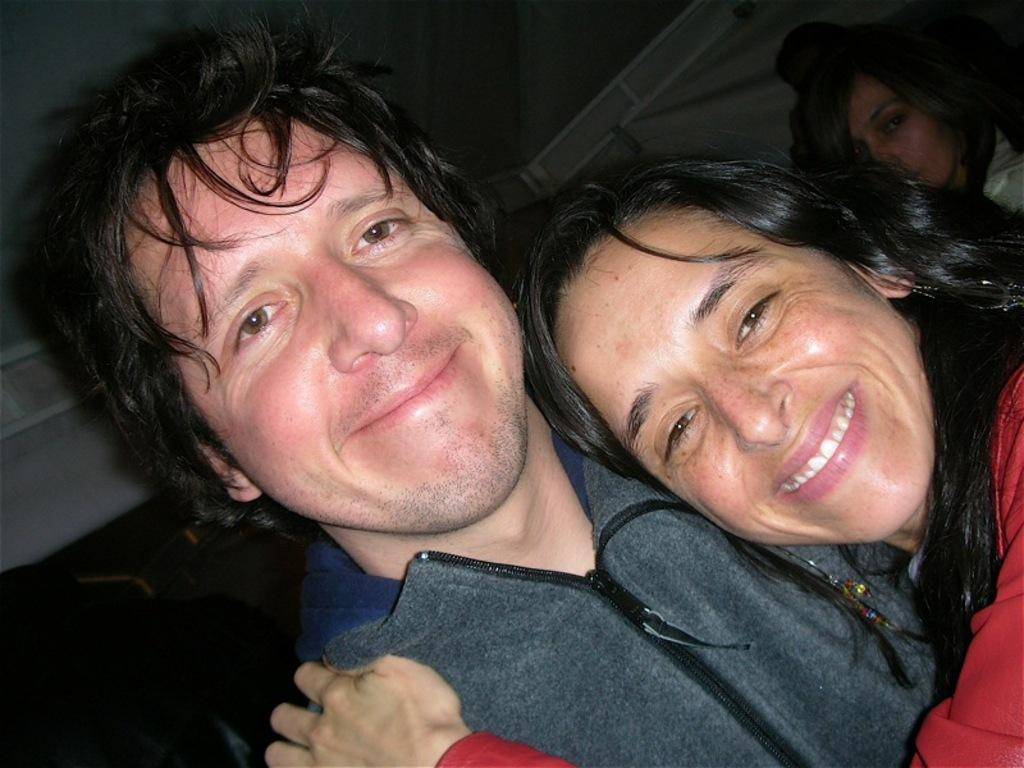Who is the main subject in the image? There is a woman in the image. What is the woman doing in the image? The woman is laying on the shoulder of a man. Can you describe the position of the man in relation to the woman? The man is beside the woman. What else can be seen in the background of the image? There is another woman in the background of the image. What is visible at the top of the image? The ceiling is visible at the top of the image. What type of pizzas are being served for breakfast in the image? There is no mention of pizzas or breakfast in the image; it features a woman laying on the shoulder of a man, with another woman in the background. 